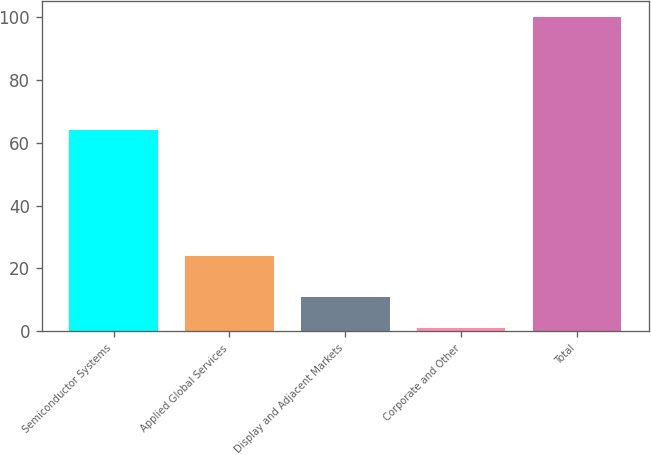<chart> <loc_0><loc_0><loc_500><loc_500><bar_chart><fcel>Semiconductor Systems<fcel>Applied Global Services<fcel>Display and Adjacent Markets<fcel>Corporate and Other<fcel>Total<nl><fcel>64<fcel>24<fcel>11<fcel>1<fcel>100<nl></chart> 